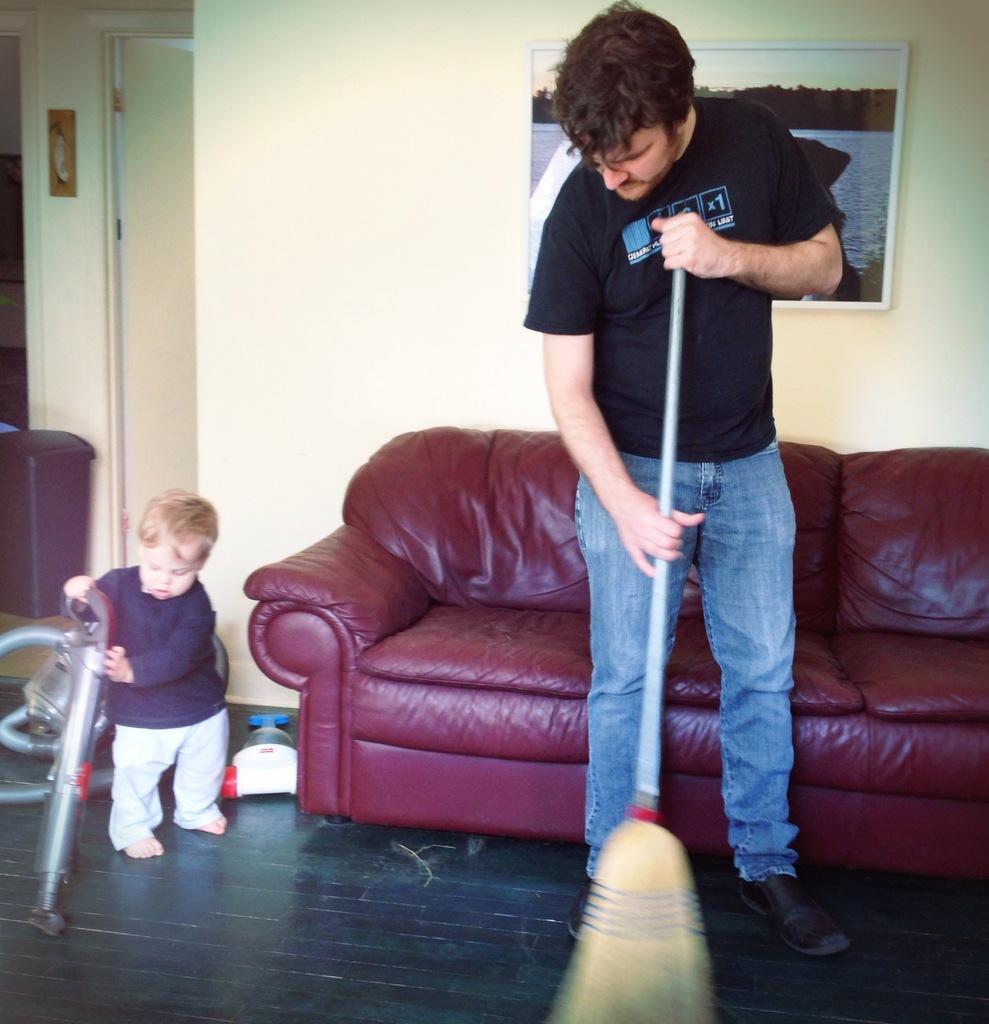Please provide a concise description of this image. In this image there is a man and a boy cleaning the floor, a man is holding a stick and the boy is holding vacuum cleaner, in the background there is a sofa and a wall, for that wall there is a photo frame. 